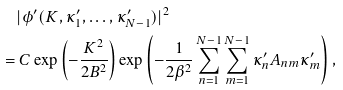<formula> <loc_0><loc_0><loc_500><loc_500>& \quad | \phi ^ { \prime } ( K , \kappa _ { 1 } ^ { \prime } , \dots , \kappa _ { N - 1 } ^ { \prime } ) | ^ { 2 } \\ & = C \exp \left ( - \frac { K ^ { 2 } } { 2 B ^ { 2 } } \right ) \exp \left ( - \frac { 1 } { 2 \beta ^ { 2 } } \sum _ { n = 1 } ^ { N - 1 } \sum _ { m = 1 } ^ { N - 1 } \kappa _ { n } ^ { \prime } A _ { n m } \kappa _ { m } ^ { \prime } \right ) ,</formula> 